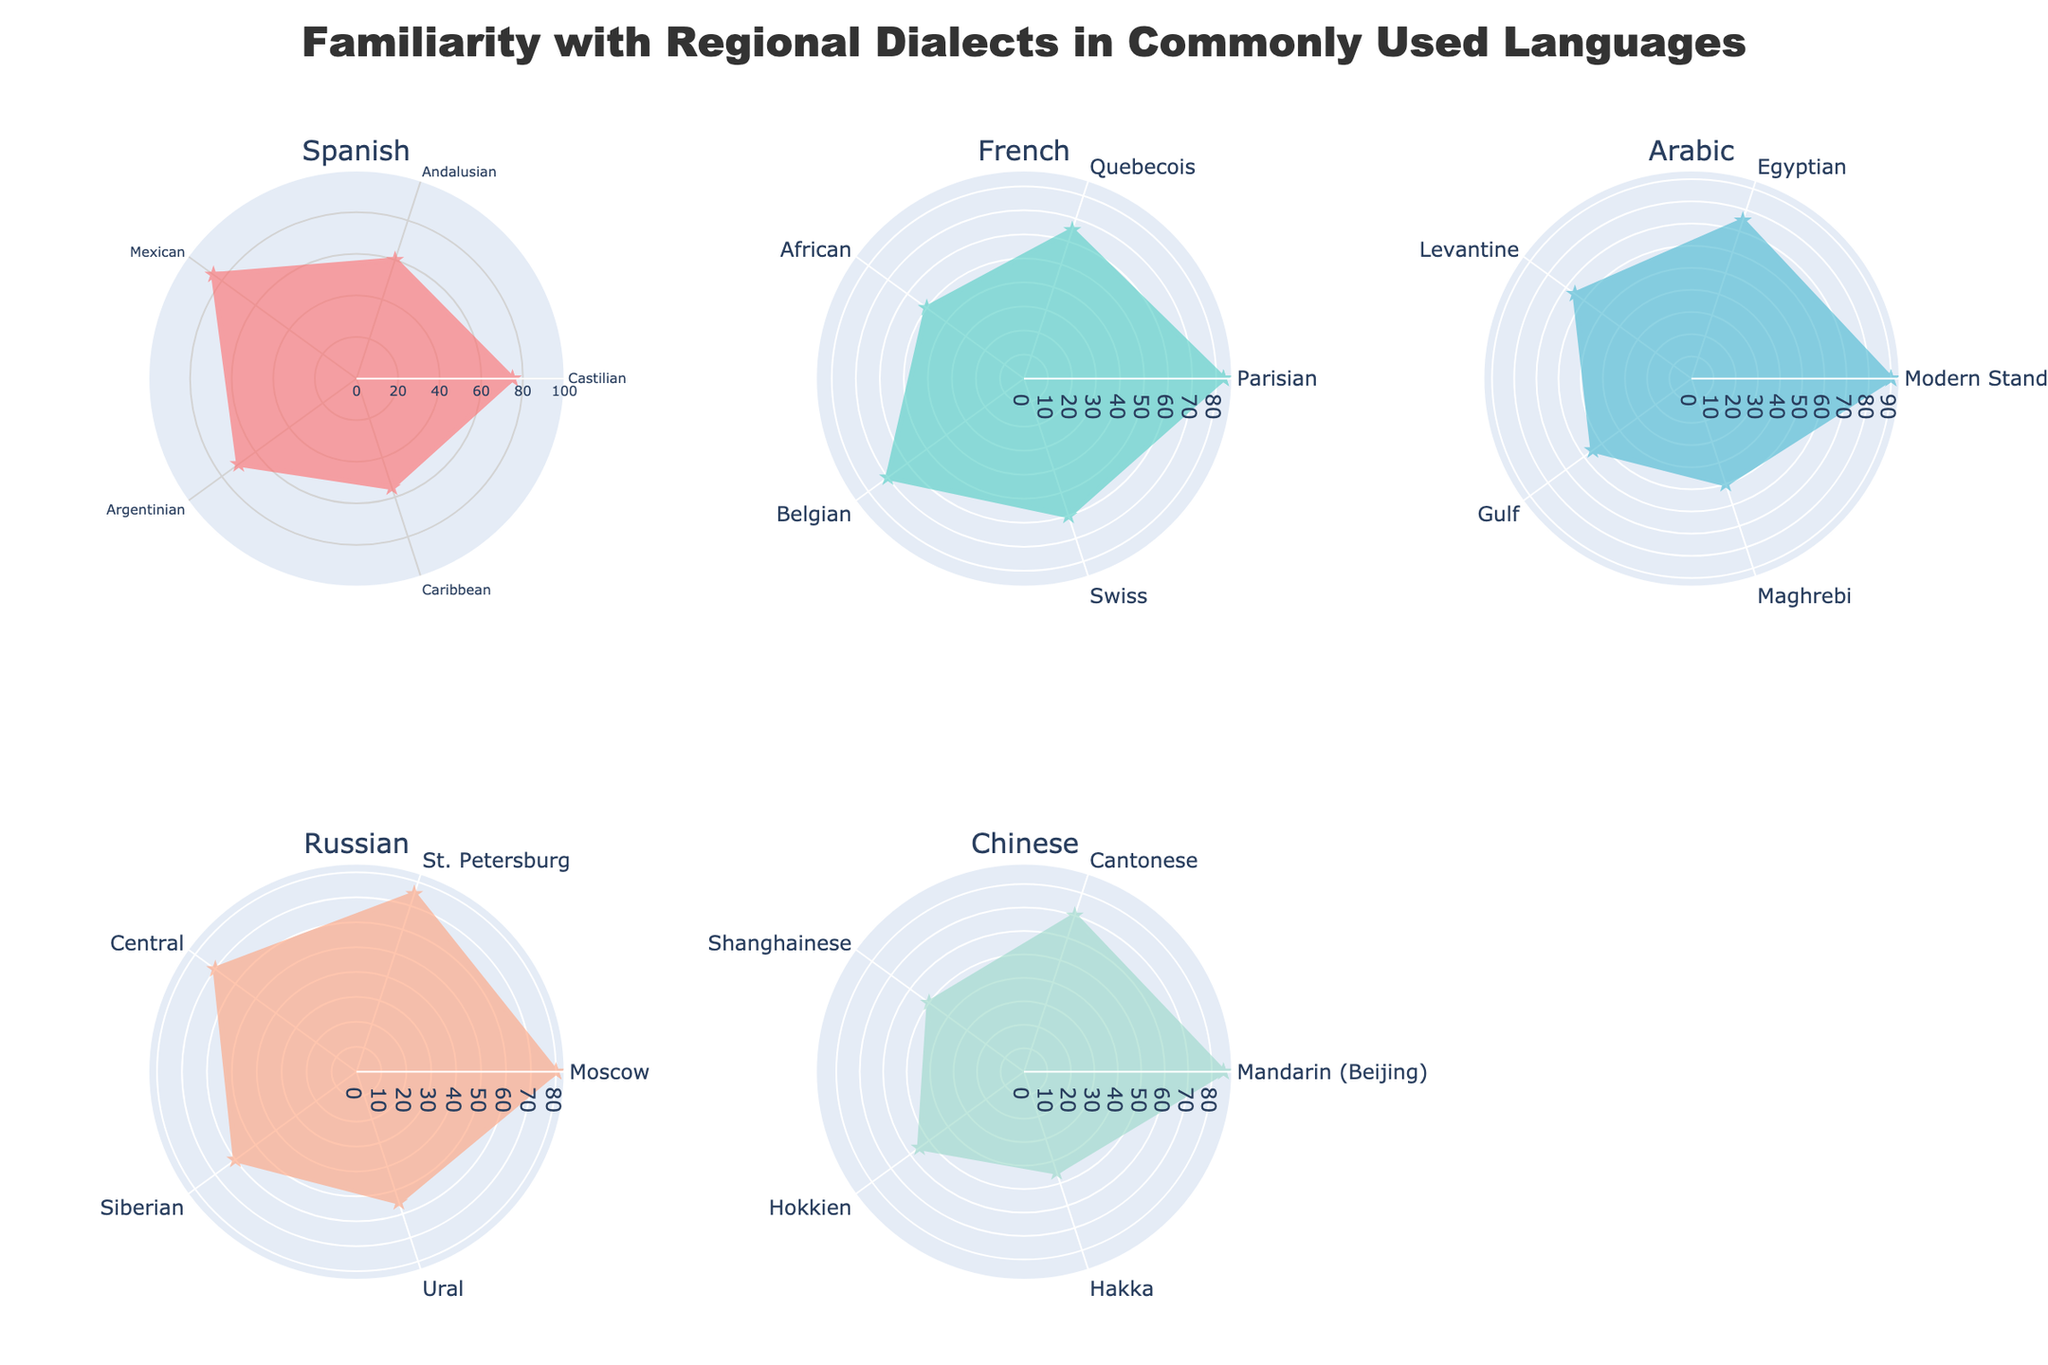What is the title of the figure? The title is prominently displayed at the top center of the figure.
Answer: Familiarity with Regional Dialects in Commonly Used Languages In the radar chart for French, which dialect has the highest familiarity level? The Parisian dialect has the highest value on the French radar chart, making it clear that it has the highest familiarity level.
Answer: Parisian What is the familiarity level of the Mandarin (Beijing) dialect in the Chinese radar chart? Look at the radar chart for Chinese, identify the plot corresponding to the Mandarin (Beijing) dialect, and read the value on the radial axis.
Answer: 85 Compare the familiarity levels of the Siberian and Ural dialects of Russian. Which is higher? Observe the radar chart for Russian, locate the plots for Siberian and Ural dialects, and compare their values. The Siberian dialect has a higher familiarity level.
Answer: Siberian Calculate the average familiarity level of all Arabic dialects. Sum all familiarity levels of the Arabic dialects (90 + 75 + 65 + 55 + 50) and divide by the number of dialects (5).
Answer: (90 + 75 + 65 + 55 + 50) / 5 = 67 Which Spanish dialect shows a familiarity level of under 60 on the radar chart? Check each plot for the Spanish radar chart and identify which dialect has a value less than 60. The Caribbean dialect fits this criterion.
Answer: Caribbean Compare the average familiarity levels between French and Chinese dialects. Which language has a higher average familiarity level? Calculate the average for both French (83 + 65 + 50 + 70 + 60) and Chinese (85 + 70 + 50 + 55 + 45) dialects, and then compare the results.
Answer: French: 65.6, Chinese: 61; French has a higher average Which language shows the most balanced familiarity levels across all its dialects? A balanced radar chart would have similar values for all dialects. Observe all subplots to see which language's plot appears most uniform. French appears the most balanced.
Answer: French Identify the least familiar dialect across all the languages depicted in the figure. Locate the lowest value across all subplots and identify the corresponding dialect. The Hakka dialect in the Chinese radar chart has the lowest familiarity level.
Answer: Hakka On the Spanish radar chart, what is the difference in familiarity levels between Mexican and Argentinean dialects? Calculate the difference between the familiarity levels of the Mexican (85) and Argentinean (70) dialects.
Answer: 85 - 70 = 15 